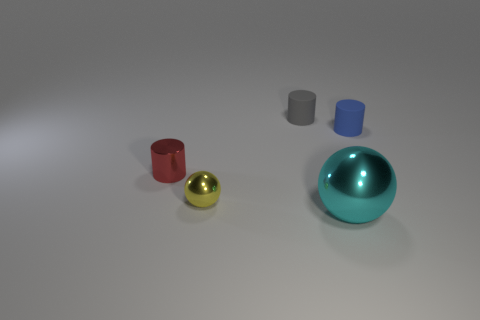Does the gray cylinder have the same material as the large cyan sphere?
Provide a succinct answer. No. Is the number of large cyan shiny balls in front of the large ball the same as the number of cylinders?
Your answer should be compact. No. How many big brown cubes have the same material as the small red cylinder?
Ensure brevity in your answer.  0. Is the number of small red matte things less than the number of blue objects?
Offer a terse response. Yes. How many gray cylinders are to the left of the thing that is behind the small matte thing that is in front of the gray thing?
Your answer should be compact. 0. What number of cyan metallic objects are behind the small red metallic cylinder?
Give a very brief answer. 0. The small shiny object that is the same shape as the tiny blue rubber thing is what color?
Your response must be concise. Red. There is a tiny cylinder that is in front of the small gray rubber cylinder and to the right of the yellow metallic sphere; what is its material?
Provide a short and direct response. Rubber. There is a rubber thing on the left side of the cyan object; is it the same size as the cyan metallic object?
Give a very brief answer. No. What material is the tiny blue object?
Give a very brief answer. Rubber. 